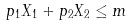<formula> <loc_0><loc_0><loc_500><loc_500>p _ { 1 } X _ { 1 } + p _ { 2 } X _ { 2 } \leq m</formula> 